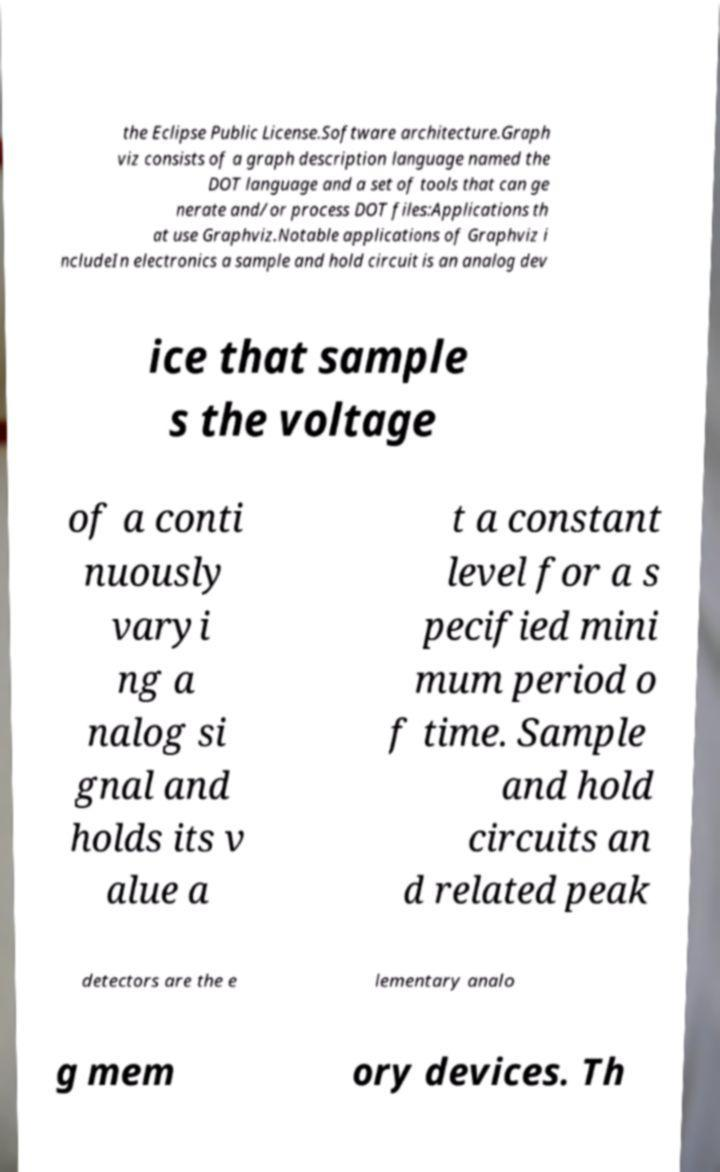Please identify and transcribe the text found in this image. the Eclipse Public License.Software architecture.Graph viz consists of a graph description language named the DOT language and a set of tools that can ge nerate and/or process DOT files:Applications th at use Graphviz.Notable applications of Graphviz i ncludeIn electronics a sample and hold circuit is an analog dev ice that sample s the voltage of a conti nuously varyi ng a nalog si gnal and holds its v alue a t a constant level for a s pecified mini mum period o f time. Sample and hold circuits an d related peak detectors are the e lementary analo g mem ory devices. Th 